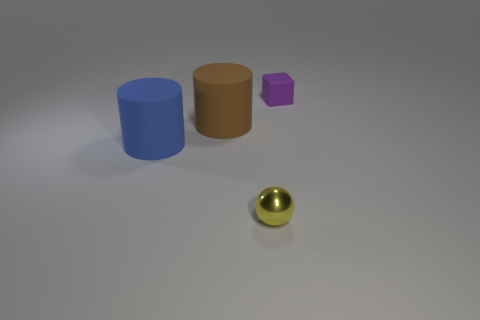Add 3 blue rubber cylinders. How many objects exist? 7 Subtract all cubes. How many objects are left? 3 Subtract all tiny balls. Subtract all brown cylinders. How many objects are left? 2 Add 4 purple rubber cubes. How many purple rubber cubes are left? 5 Add 4 brown things. How many brown things exist? 5 Subtract 1 brown cylinders. How many objects are left? 3 